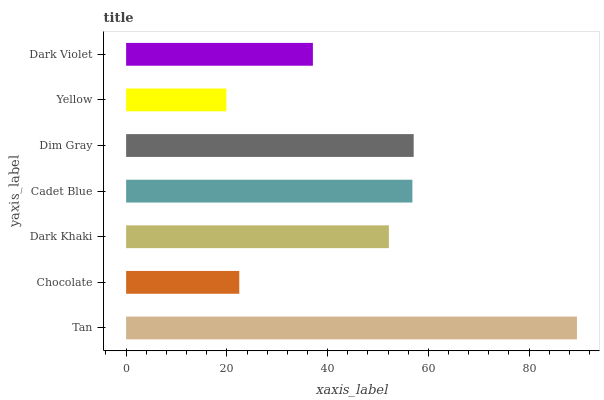Is Yellow the minimum?
Answer yes or no. Yes. Is Tan the maximum?
Answer yes or no. Yes. Is Chocolate the minimum?
Answer yes or no. No. Is Chocolate the maximum?
Answer yes or no. No. Is Tan greater than Chocolate?
Answer yes or no. Yes. Is Chocolate less than Tan?
Answer yes or no. Yes. Is Chocolate greater than Tan?
Answer yes or no. No. Is Tan less than Chocolate?
Answer yes or no. No. Is Dark Khaki the high median?
Answer yes or no. Yes. Is Dark Khaki the low median?
Answer yes or no. Yes. Is Chocolate the high median?
Answer yes or no. No. Is Chocolate the low median?
Answer yes or no. No. 